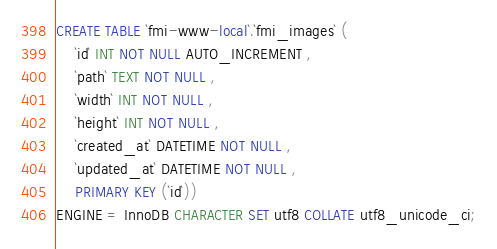Convert code to text. <code><loc_0><loc_0><loc_500><loc_500><_SQL_>CREATE TABLE `fmi-www-local`.`fmi_images` (
	`id` INT NOT NULL AUTO_INCREMENT ,
	`path` TEXT NOT NULL ,
	`width` INT NOT NULL ,
	`height` INT NOT NULL ,
	`created_at` DATETIME NOT NULL ,
	`updated_at` DATETIME NOT NULL ,
	PRIMARY KEY (`id`))
ENGINE = InnoDB CHARACTER SET utf8 COLLATE utf8_unicode_ci;</code> 